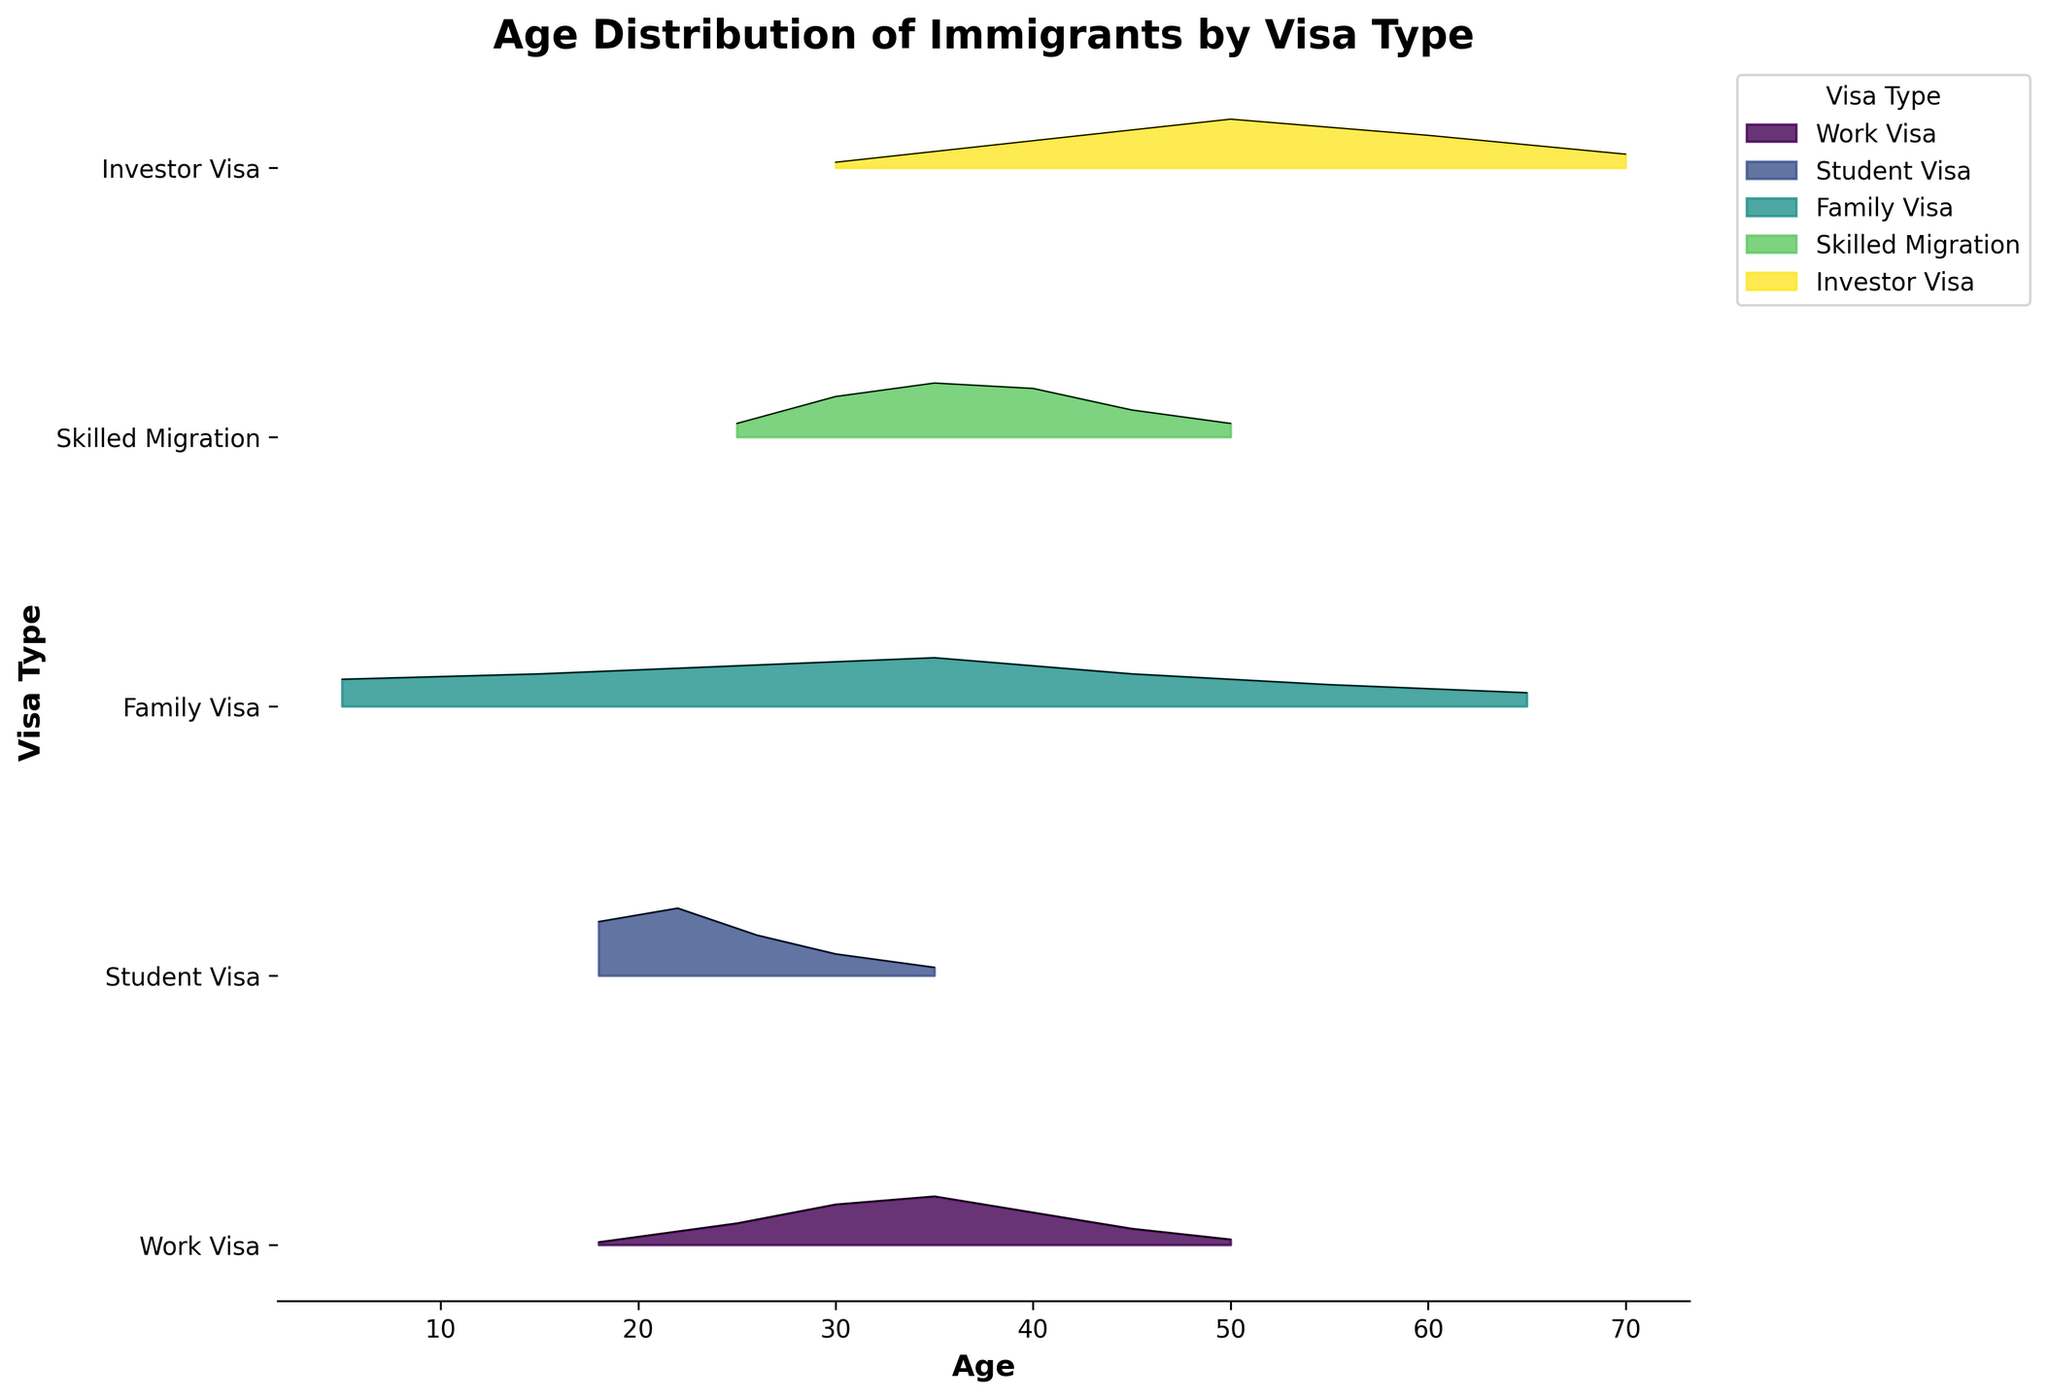What is the title of this figure? The title is usually found at the top of the figure and identifies the main subject matter being depicted. In this case, it's about the age distribution of immigrants.
Answer: Age Distribution of Immigrants by Visa Type Which visa type appears to have the most substantial age density for ages between 18 and 30? By analyzing the plot's peaks and density areas, we observe the density values for each visa type in the 18 to 30 age range. The Student Visa shows high density peaks at 18 and 22.
Answer: Student Visa Which visa type has the oldest peak in age distribution? Look for the highest density value at the oldest age among all visa types. The Investor Visa shows a significant peak at age 60.
Answer: Investor Visa For which age range does the Family Visa have the highest density? Examining the ridgeline for the Family Visa, we see the highest peak of density at age 35.
Answer: 35 How does the age distribution for the Work Visa differ from that of the Skilled Migration Visa? Compare the peaks and density ranges of both visa types. The Work Visa has higher density in the 30-40 age range, while the Skilled Migration Visa shows significant density in the 30-45 age range, with a notable peak at 35.
Answer: Work Visa peaks at 30-40; Skilled Migration peaks at 30-45 Which visa type covers the broadest age range in the figure? Identify the visa type with the widest spread of density across ages. The Family Visa spans from age 5 to 65.
Answer: Family Visa What is the peak age density for the Investor Visa? Locate the highest point on the ridge line for the Investor Visa. The peak age density occurs at age 50.
Answer: 50 If a 25-year-old applies, which visa types show significant density for this age? Identify the visa types with considerable density at age 25 by looking at density values near this age. Work Visa, Student Visa, Family Visa, and Skilled Migration have notable densities at this age.
Answer: Work Visa, Student Visa, Family Visa, Skilled Migration 